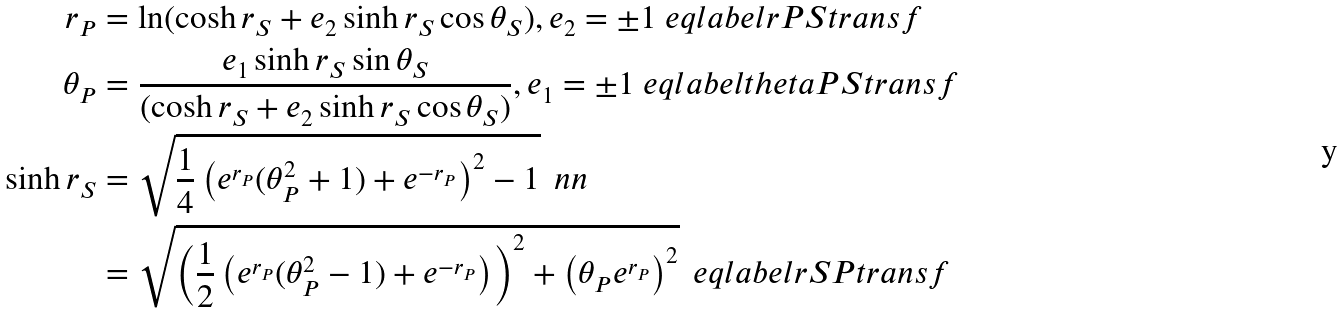<formula> <loc_0><loc_0><loc_500><loc_500>r _ { P } & = \ln ( \cosh r _ { S } + e _ { 2 } \sinh r _ { S } \cos \theta _ { S } ) , e _ { 2 } = \pm 1 \ e q l a b e l { r P S t r a n s f } \\ \theta _ { P } & = \frac { e _ { 1 } \sinh r _ { S } \sin \theta _ { S } } { ( \cosh r _ { S } + e _ { 2 } \sinh r _ { S } \cos \theta _ { S } ) } , e _ { 1 } = \pm 1 \ e q l a b e l { t h e t a P S t r a n s f } \\ \sinh r _ { S } & = \sqrt { \frac { 1 } { 4 } \left ( e ^ { r _ { P } } ( \theta _ { P } ^ { 2 } + 1 ) + e ^ { - r _ { P } } \right ) ^ { 2 } - 1 } \, \ n n \\ & = \sqrt { \left ( \frac { 1 } { 2 } \left ( e ^ { r _ { P } } ( \theta _ { P } ^ { 2 } - 1 ) + e ^ { - r _ { P } } \right ) \right ) ^ { 2 } + \left ( \theta _ { P } e ^ { r _ { P } } \right ) ^ { 2 } } \, \ e q l a b e l { r S P t r a n s f }</formula> 